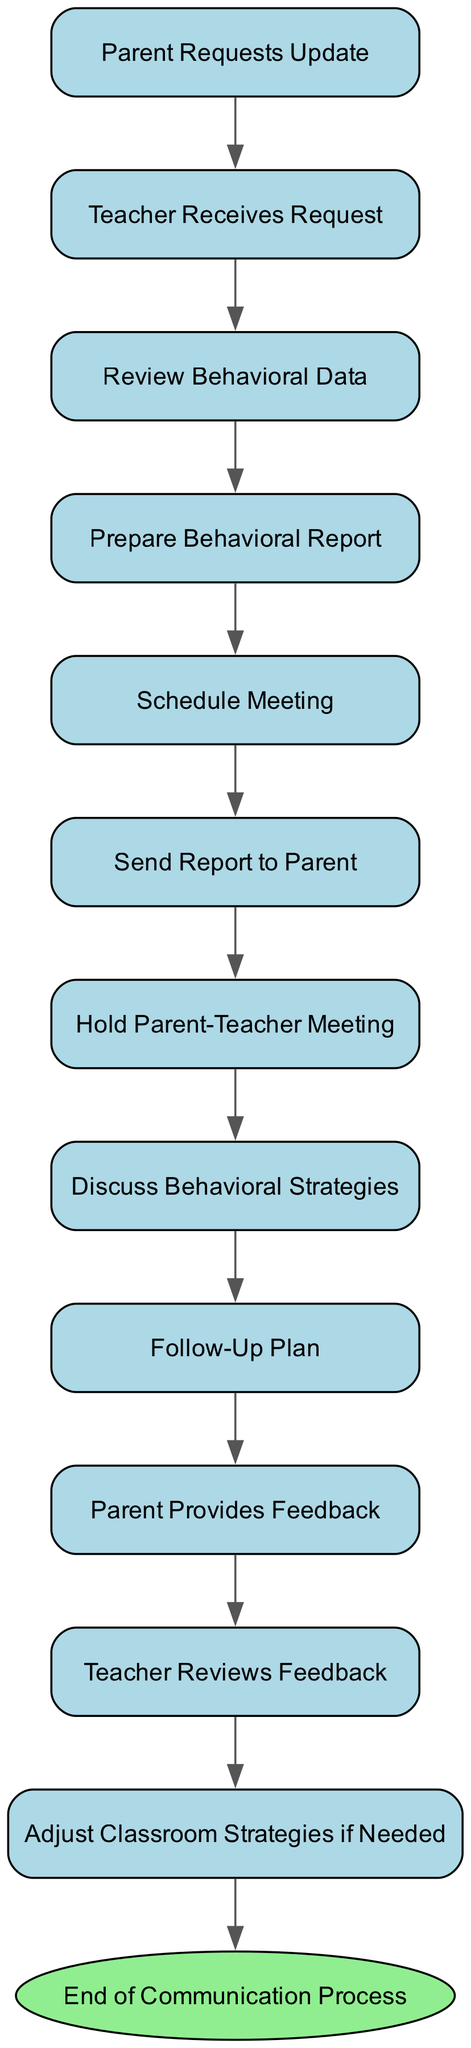What is the first action in the process? The first action node in the diagram is labeled "Parent Requests Update." It is the starting point of the communication process as indicated by its position at the top of the diagram.
Answer: Parent Requests Update What is the last action before the process ends? The last action before the end node is "Adjust Classroom Strategies if Needed." This is determined by following the flow of actions from the start to the end, stopping just before the end node.
Answer: Adjust Classroom Strategies if Needed How many total actions are illustrated in the diagram? Counting all action nodes, there are 12 action nodes in total in the diagram. This includes all actions from "Parent Requests Update" to "Adjust Classroom Strategies if Needed."
Answer: 12 How many meetings are scheduled in the communication process? There is only one meeting explicitly mentioned in the diagram, which is "Hold Parent-Teacher Meeting." Thus, it is the only meeting indicated in the flow.
Answer: 1 What action follows "Send Report to Parent"? The action that follows "Send Report to Parent" is "Hold Parent-Teacher Meeting," as seen in the direct connection from one action node to the next in the flow.
Answer: Hold Parent-Teacher Meeting Which action is directly related to feedback from the parent? The action directly related to feedback is "Parent Provides Feedback." It is linked sequentially in the flow after the meeting where strategies are discussed.
Answer: Parent Provides Feedback Which actions involve preparation or review? The actions involving preparation or review are "Review Behavioral Data," "Prepare Behavioral Report," and "Teacher Reviews Feedback." These actions focus on analyzing and preparing information during the process.
Answer: Review Behavioral Data, Prepare Behavioral Report, Teacher Reviews Feedback How does the diagram show adjustments to the classroom strategies? Adjustments to classroom strategies are depicted through the action "Adjust Classroom Strategies if Needed," which occurs after "Teacher Reviews Feedback," indicating a reaction to the feedback provided by the parent.
Answer: Adjust Classroom Strategies if Needed 